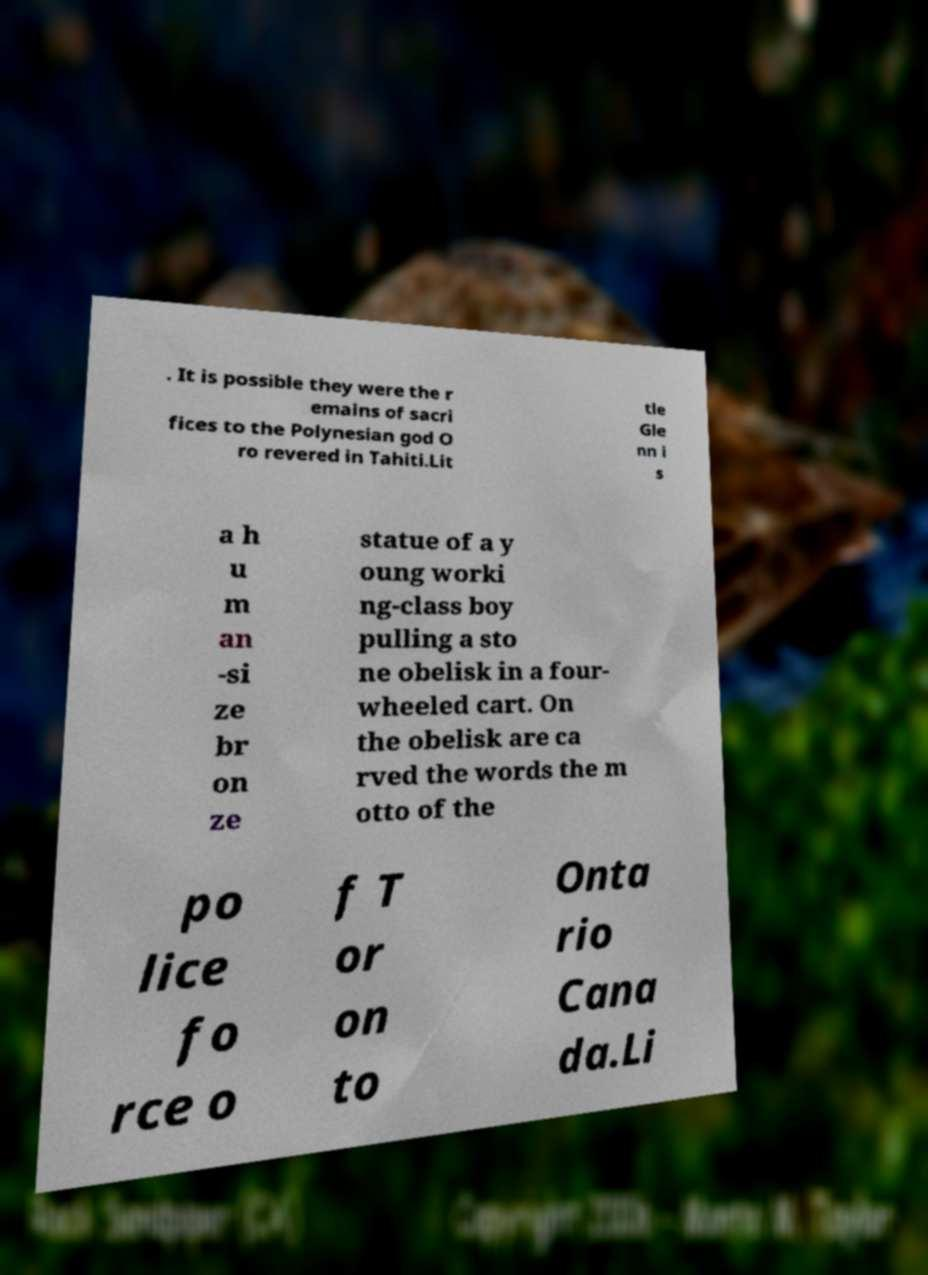For documentation purposes, I need the text within this image transcribed. Could you provide that? . It is possible they were the r emains of sacri fices to the Polynesian god O ro revered in Tahiti.Lit tle Gle nn i s a h u m an -si ze br on ze statue of a y oung worki ng-class boy pulling a sto ne obelisk in a four- wheeled cart. On the obelisk are ca rved the words the m otto of the po lice fo rce o f T or on to Onta rio Cana da.Li 